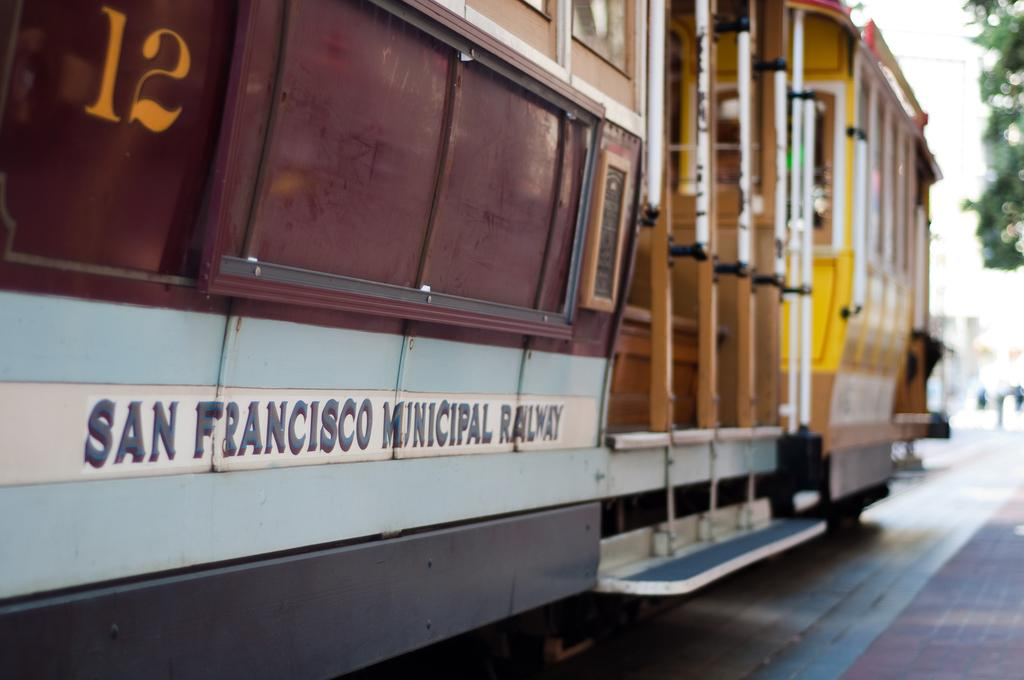What is the main subject of the image? The main subject of the image is a train. What can be found attached to the train? The train has a coach. How would you describe the background of the image? The background of the image appears blurry. Is there any additional feature attached to the coach? Yes, there is a frame attached to the coach. What type of stitch is used to attach the cannon to the train in the image? There is no cannon present in the image, so there is no stitch used to attach it. What grade does the train receive for its appearance in the image? The image does not include any grading system, so it cannot be graded. 